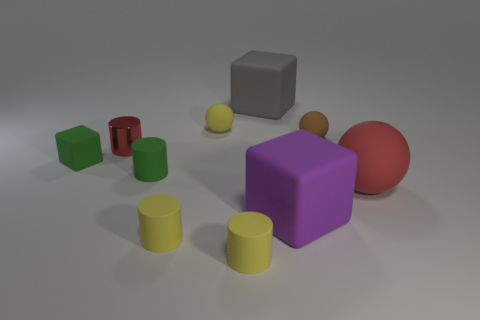Subtract all green cylinders. How many cylinders are left? 3 Subtract all brown balls. How many balls are left? 2 Subtract all purple cubes. How many gray balls are left? 0 Subtract all balls. How many objects are left? 7 Subtract 1 spheres. How many spheres are left? 2 Subtract all blue spheres. Subtract all green cylinders. How many spheres are left? 3 Subtract all large yellow shiny balls. Subtract all yellow balls. How many objects are left? 9 Add 5 tiny red shiny things. How many tiny red shiny things are left? 6 Add 8 small purple rubber objects. How many small purple rubber objects exist? 8 Subtract 0 blue cubes. How many objects are left? 10 